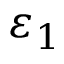Convert formula to latex. <formula><loc_0><loc_0><loc_500><loc_500>\varepsilon _ { 1 }</formula> 